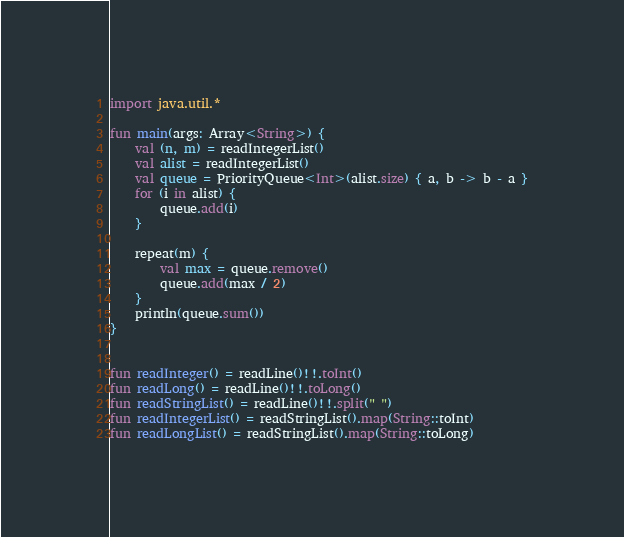Convert code to text. <code><loc_0><loc_0><loc_500><loc_500><_Kotlin_>import java.util.*

fun main(args: Array<String>) {
    val (n, m) = readIntegerList()
    val alist = readIntegerList()
    val queue = PriorityQueue<Int>(alist.size) { a, b -> b - a }
    for (i in alist) {
        queue.add(i)
    }

    repeat(m) {
        val max = queue.remove()
        queue.add(max / 2)
    }
    println(queue.sum())
}


fun readInteger() = readLine()!!.toInt()
fun readLong() = readLine()!!.toLong()
fun readStringList() = readLine()!!.split(" ")
fun readIntegerList() = readStringList().map(String::toInt)
fun readLongList() = readStringList().map(String::toLong)
</code> 